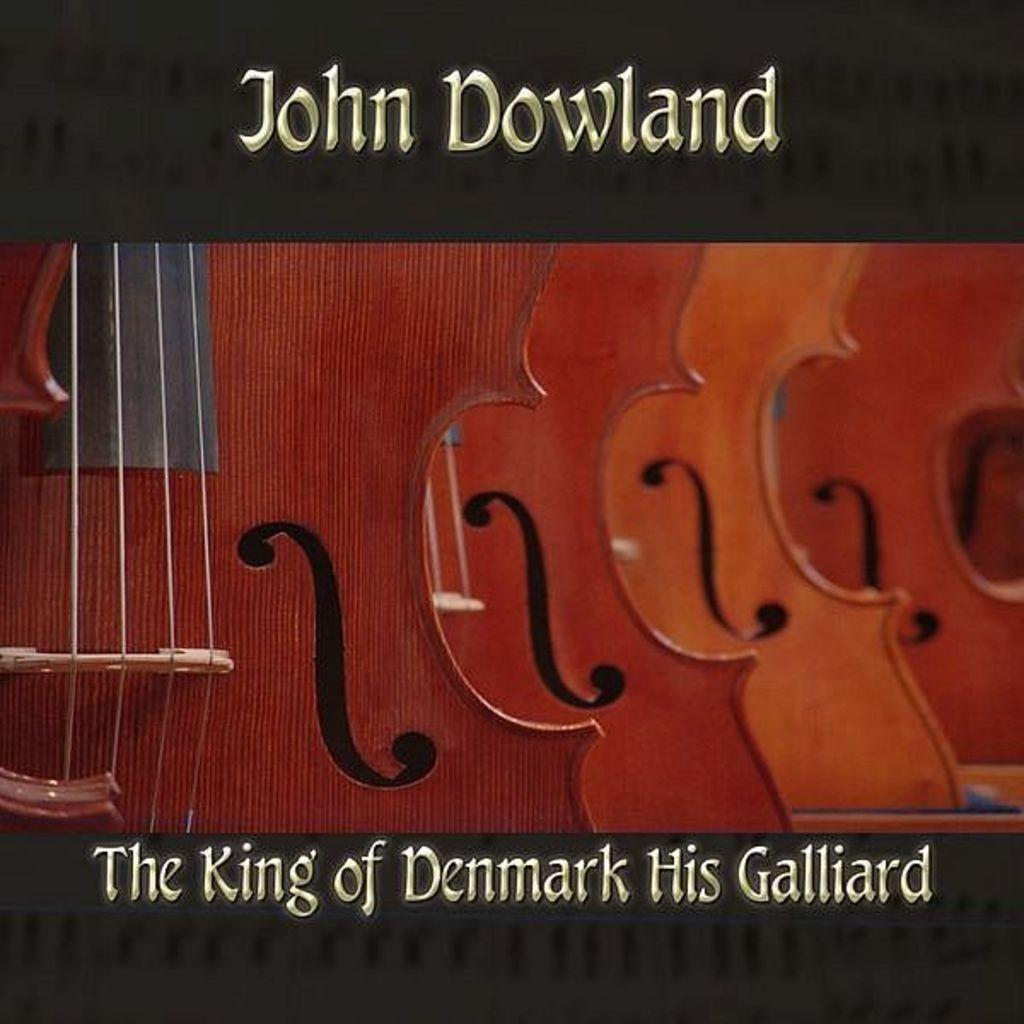What type of objects can be seen in the image? There are musical instruments in the image. Can you describe the musical instruments in more detail? Unfortunately, the provided facts do not give enough information to describe the musical instruments in more detail. Are there any other objects or people present in the image? The provided facts do not mention any other objects or people in the image. What page of the fiction novel is the badge mentioned on? There is no mention of a fiction novel or a badge in the image, so this question cannot be answered. 